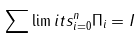Convert formula to latex. <formula><loc_0><loc_0><loc_500><loc_500>\sum \lim i t s _ { i = 0 } ^ { n } \Pi _ { i } = I</formula> 